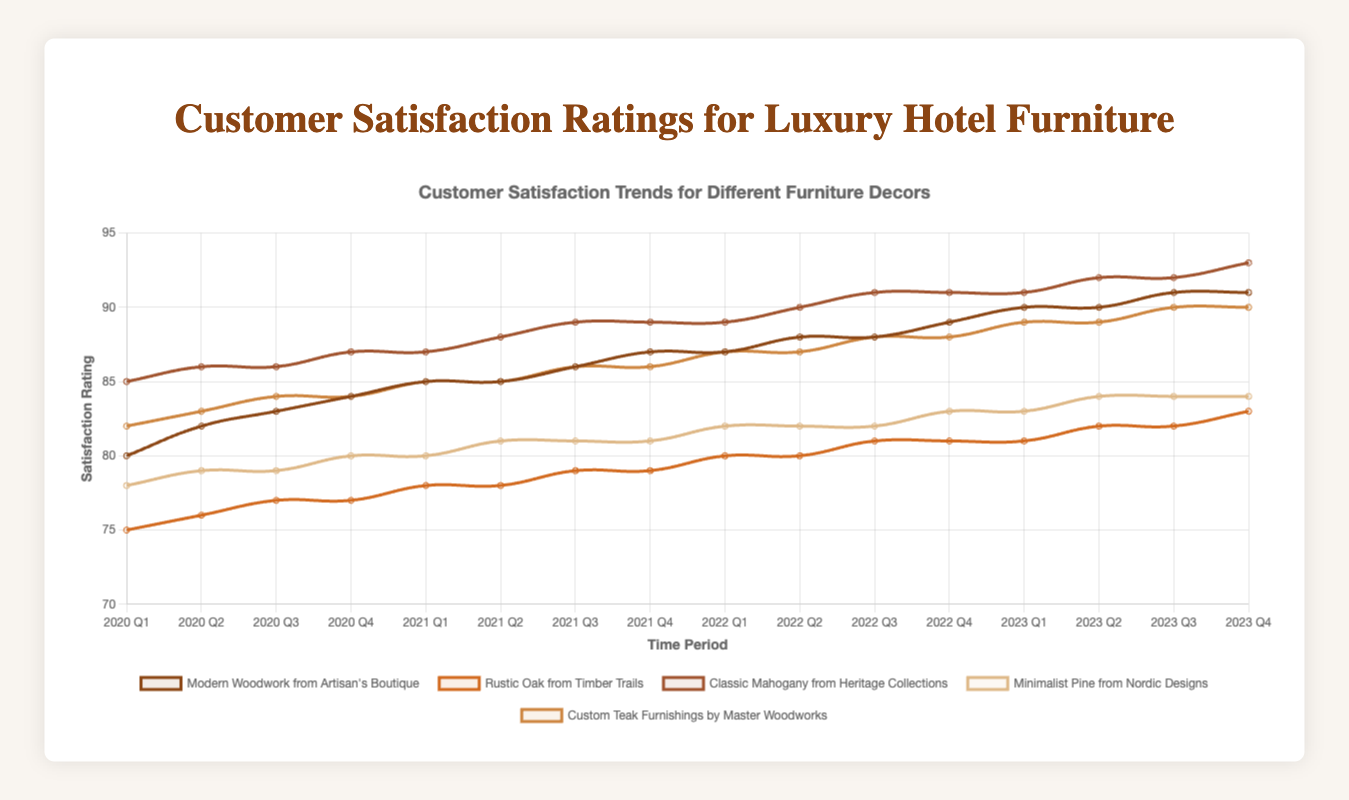Which furniture decor has the highest customer satisfaction rating in 2023 Q4? To find the highest rating, compare the satisfaction ratings for each furniture decor in 2023 Q4. Classic Mahogany from Heritage Collections has the highest rating of 93.
Answer: Classic Mahogany from Heritage Collections How has the satisfaction for Modern Woodwork from Artisan's Boutique changed from 2020 Q1 to 2023 Q4? The satisfaction rating for Modern Woodwork from Artisan's Boutique started at 80 in 2020 Q1 and increased to 91 in 2023 Q4, showing a consistent increase over time.
Answer: Increased by 11 points Which furniture decor shows the most consistent satisfaction ratings over time? Check the stability and variations in the satisfaction ratings of each furniture decor. Minimalist Pine from Nordic Designs shows more consistent ratings with slight increases, staying within a range of 78 to 84.
Answer: Minimalist Pine from Nordic Designs Between Rustic Oak from Timber Trails and Custom Teak Furnishings by Master Woodworks, which had higher satisfaction ratings in 2021 Q3? In 2021 Q3, compare the ratings for Rustic Oak from Timber Trails (79) and Custom Teak Furnishings by Master Woodworks (86).
Answer: Custom Teak Furnishings by Master Woodworks How does the customer satisfaction trend of Classic Mahogany from Heritage Collections compare to Minimalist Pine from Nordic Designs? Classic Mahogany consistently shows higher satisfaction and a steady increase from 85 to 93. Minimalist Pine rises steadily as well but starts from 78 and tops out at 84. Classic Mahogany always holds higher ratings.
Answer: Classic Mahogany has a higher and more consistent increase What is the average customer satisfaction rating for Rustic Oak from Timber Trails in 2021? The ratings for Rustic Oak from Timber Trails in 2021 are 78, 78, 79, and 79. The average is calculated as (78 + 78 + 79 + 79) / 4.
Answer: 78.5 Which decor had the lowest customer satisfaction rating in any of the quarters shown? To find the lowest rating, look at all data points for each decor. The lowest is 75 for Rustic Oak from Timber Trails in 2020 Q1.
Answer: Rustic Oak from Timber Trails in 2020 Q1 By how much did the satisfaction rating for Minimalist Pine from Nordic Designs increase from its lowest to highest point? The lowest rating for Minimalist Pine is 78 and the highest is 84. The increase is 84 - 78.
Answer: Increased by 6 points Among the listed furniture decors, which had the fastest growth in customer satisfaction from 2020 Q1 to 2020 Q2? Compare the increase from 2020 Q1 to 2020 Q2 for all decors. Modern Woodwork from Artisan's Boutique and Custom Teak Furnishings by Master Woodworks both increased by 2 points (80 to 82 and 82 to 84).
Answer: Modern Woodwork from Artisan's Boutique and Custom Teak Furnishings by Master Woodworks What is the difference in satisfaction between the highest and lowest rated decors in 2022 Q4? In 2022 Q4, the highest rating is 91 (Classic Mahogany) and the lowest is 83 (Rustic Oak). The difference is 91 - 83.
Answer: 8 points 